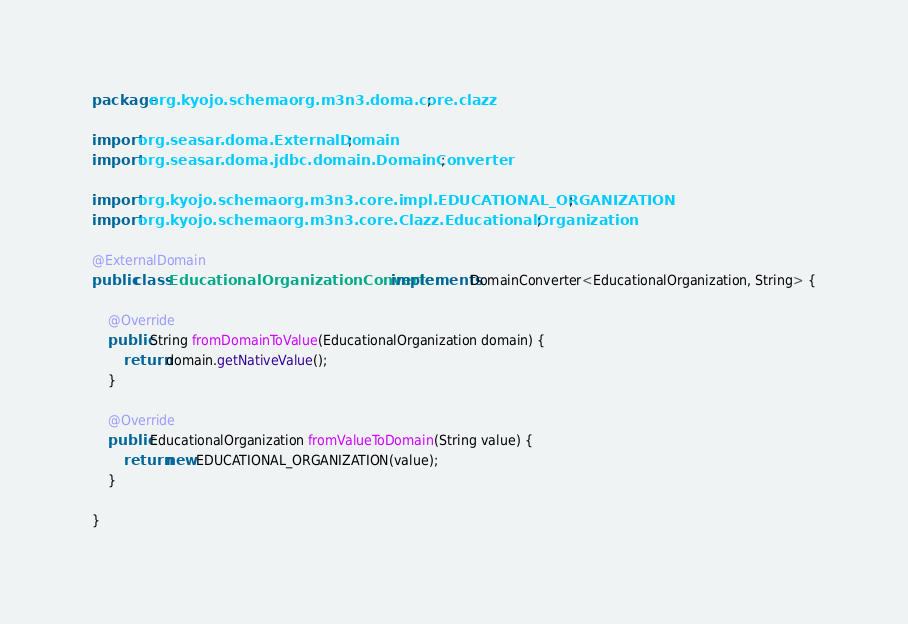Convert code to text. <code><loc_0><loc_0><loc_500><loc_500><_Java_>package org.kyojo.schemaorg.m3n3.doma.core.clazz;

import org.seasar.doma.ExternalDomain;
import org.seasar.doma.jdbc.domain.DomainConverter;

import org.kyojo.schemaorg.m3n3.core.impl.EDUCATIONAL_ORGANIZATION;
import org.kyojo.schemaorg.m3n3.core.Clazz.EducationalOrganization;

@ExternalDomain
public class EducationalOrganizationConverter implements DomainConverter<EducationalOrganization, String> {

	@Override
	public String fromDomainToValue(EducationalOrganization domain) {
		return domain.getNativeValue();
	}

	@Override
	public EducationalOrganization fromValueToDomain(String value) {
		return new EDUCATIONAL_ORGANIZATION(value);
	}

}
</code> 